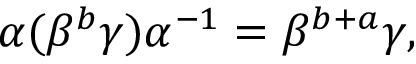Convert formula to latex. <formula><loc_0><loc_0><loc_500><loc_500>\alpha ( \beta ^ { b } \gamma ) \alpha ^ { - 1 } = \beta ^ { b + a } \gamma ,</formula> 